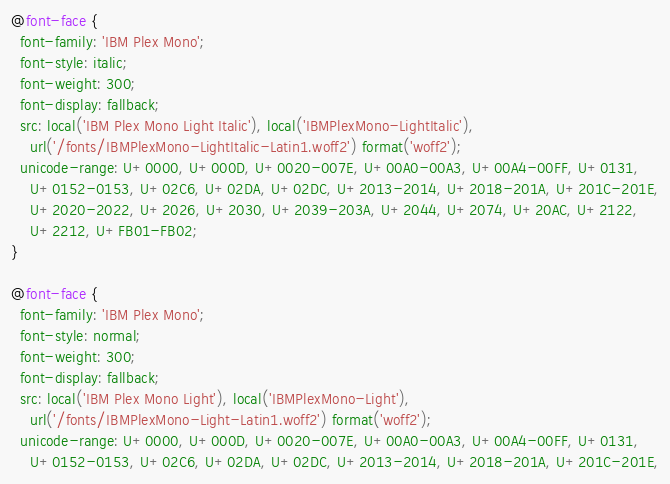Convert code to text. <code><loc_0><loc_0><loc_500><loc_500><_CSS_>@font-face {
  font-family: 'IBM Plex Mono';
  font-style: italic;
  font-weight: 300;
  font-display: fallback;
  src: local('IBM Plex Mono Light Italic'), local('IBMPlexMono-LightItalic'),
    url('/fonts/IBMPlexMono-LightItalic-Latin1.woff2') format('woff2');
  unicode-range: U+0000, U+000D, U+0020-007E, U+00A0-00A3, U+00A4-00FF, U+0131,
    U+0152-0153, U+02C6, U+02DA, U+02DC, U+2013-2014, U+2018-201A, U+201C-201E,
    U+2020-2022, U+2026, U+2030, U+2039-203A, U+2044, U+2074, U+20AC, U+2122,
    U+2212, U+FB01-FB02;
}

@font-face {
  font-family: 'IBM Plex Mono';
  font-style: normal;
  font-weight: 300;
  font-display: fallback;
  src: local('IBM Plex Mono Light'), local('IBMPlexMono-Light'),
    url('/fonts/IBMPlexMono-Light-Latin1.woff2') format('woff2');
  unicode-range: U+0000, U+000D, U+0020-007E, U+00A0-00A3, U+00A4-00FF, U+0131,
    U+0152-0153, U+02C6, U+02DA, U+02DC, U+2013-2014, U+2018-201A, U+201C-201E,</code> 